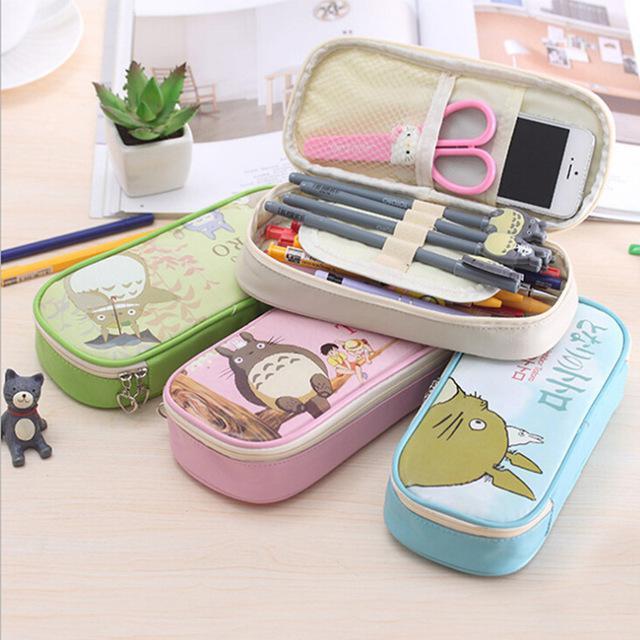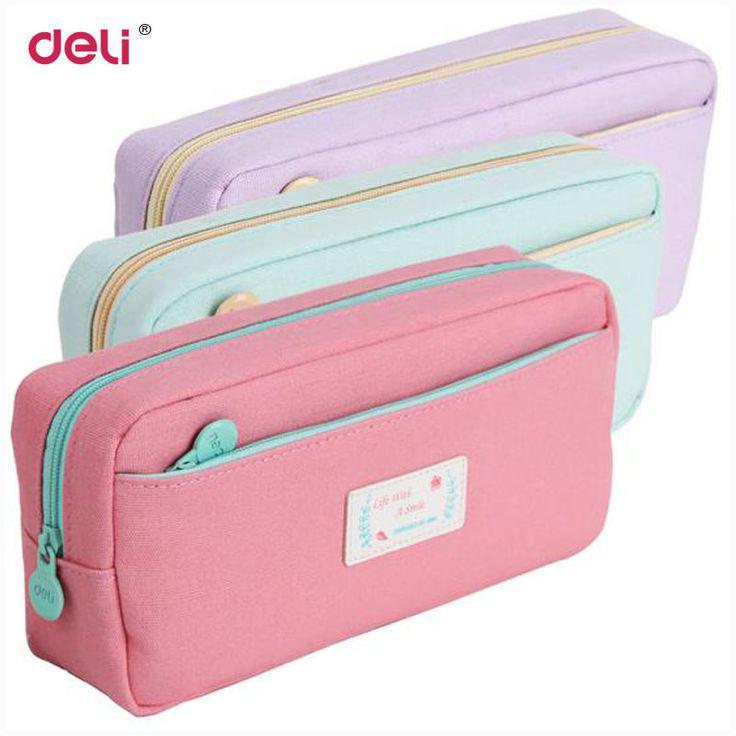The first image is the image on the left, the second image is the image on the right. Evaluate the accuracy of this statement regarding the images: "The left image shows only a single pink case.". Is it true? Answer yes or no. No. 